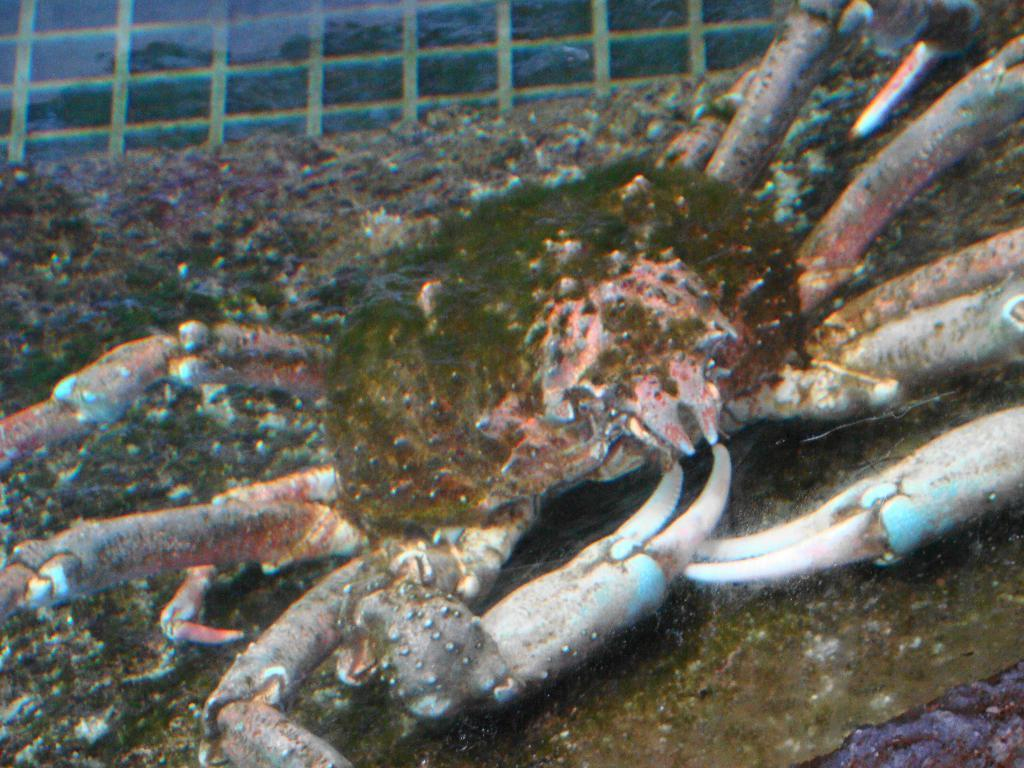What type of animal is in the image? There is a crab in the image. Can you describe the appearance of the crab? The crab has a multicolor appearance. Where is the swing located in the image? There is no swing present in the image. What type of tub is visible in the image? There is no tub present in the image. 